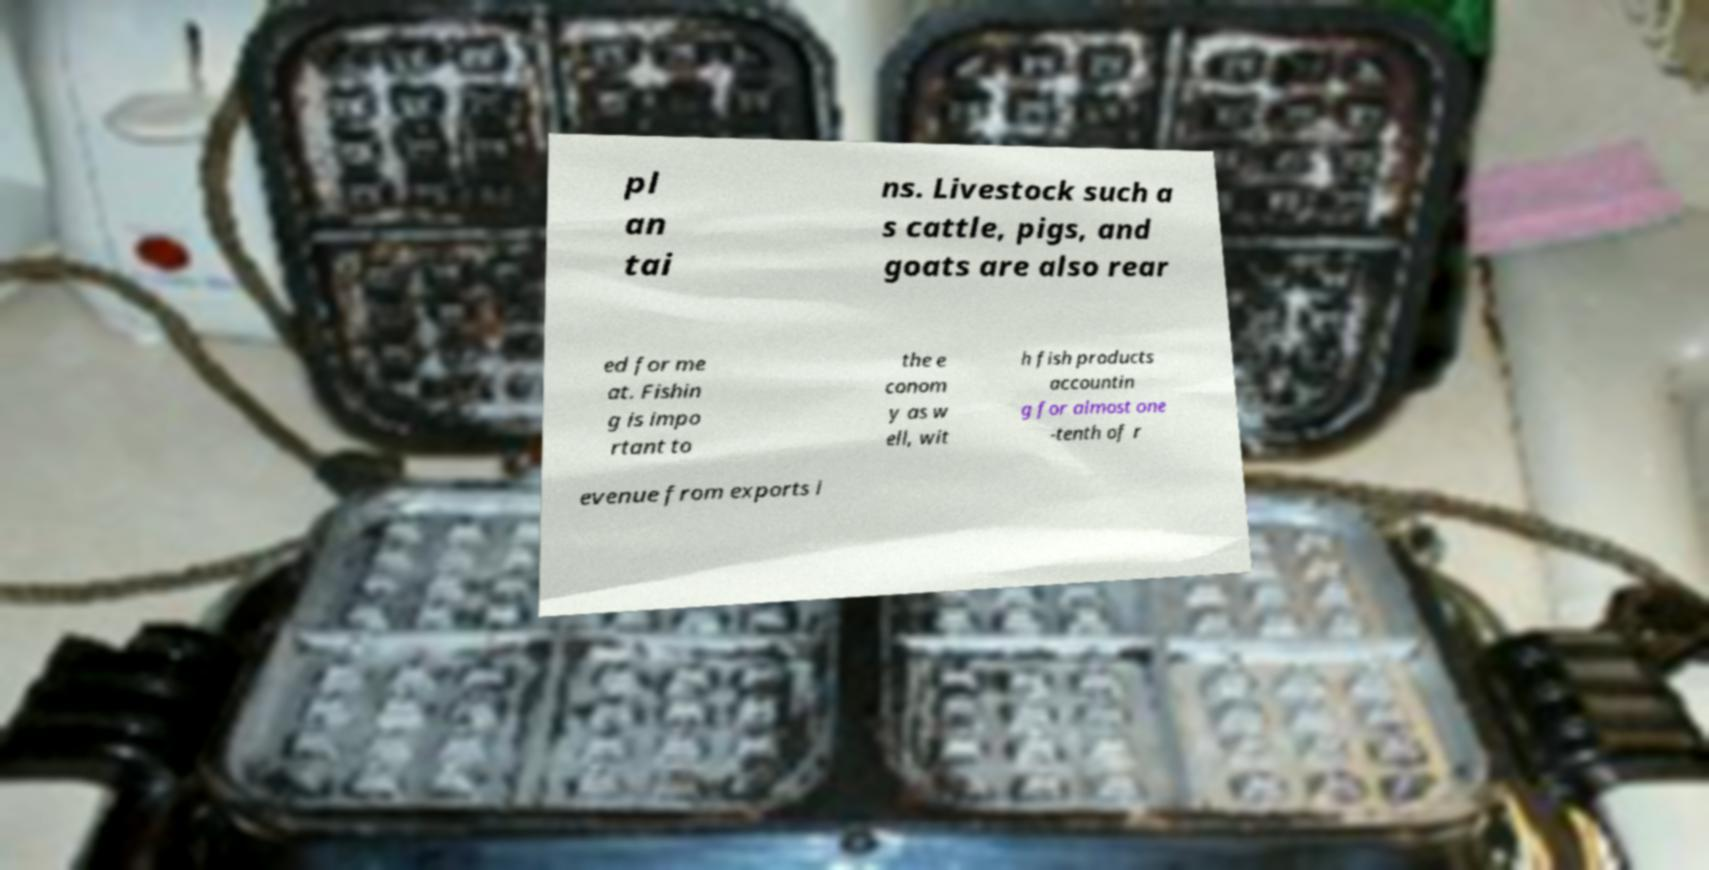I need the written content from this picture converted into text. Can you do that? pl an tai ns. Livestock such a s cattle, pigs, and goats are also rear ed for me at. Fishin g is impo rtant to the e conom y as w ell, wit h fish products accountin g for almost one -tenth of r evenue from exports i 